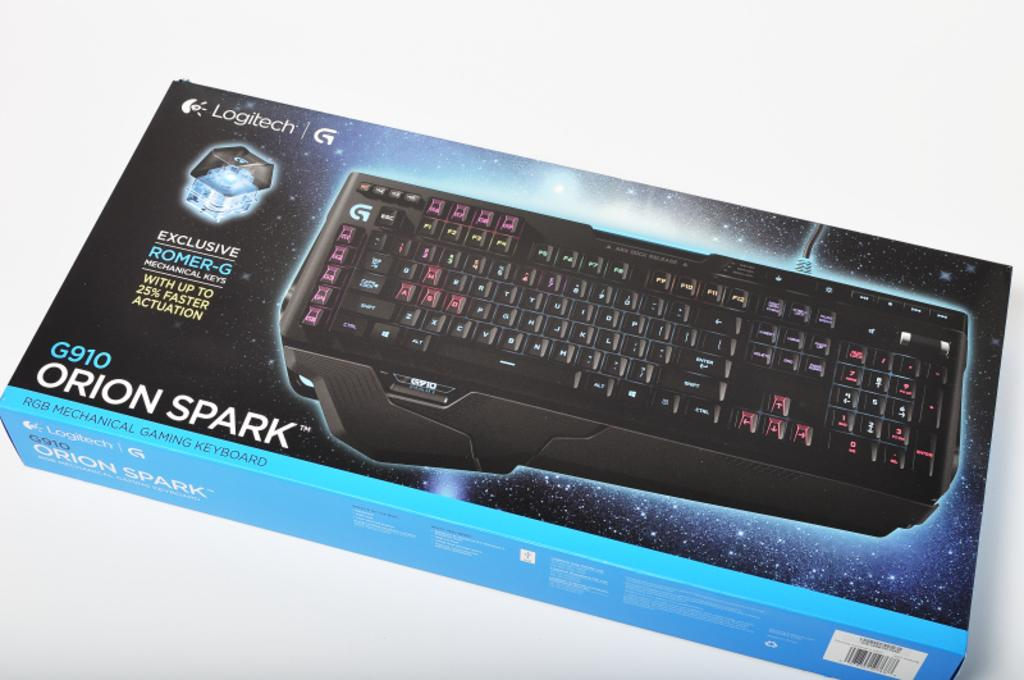<image>
Provide a brief description of the given image. The Orion Spark keyboard from Logitech comes in a blue, black and turquoise colored box. 